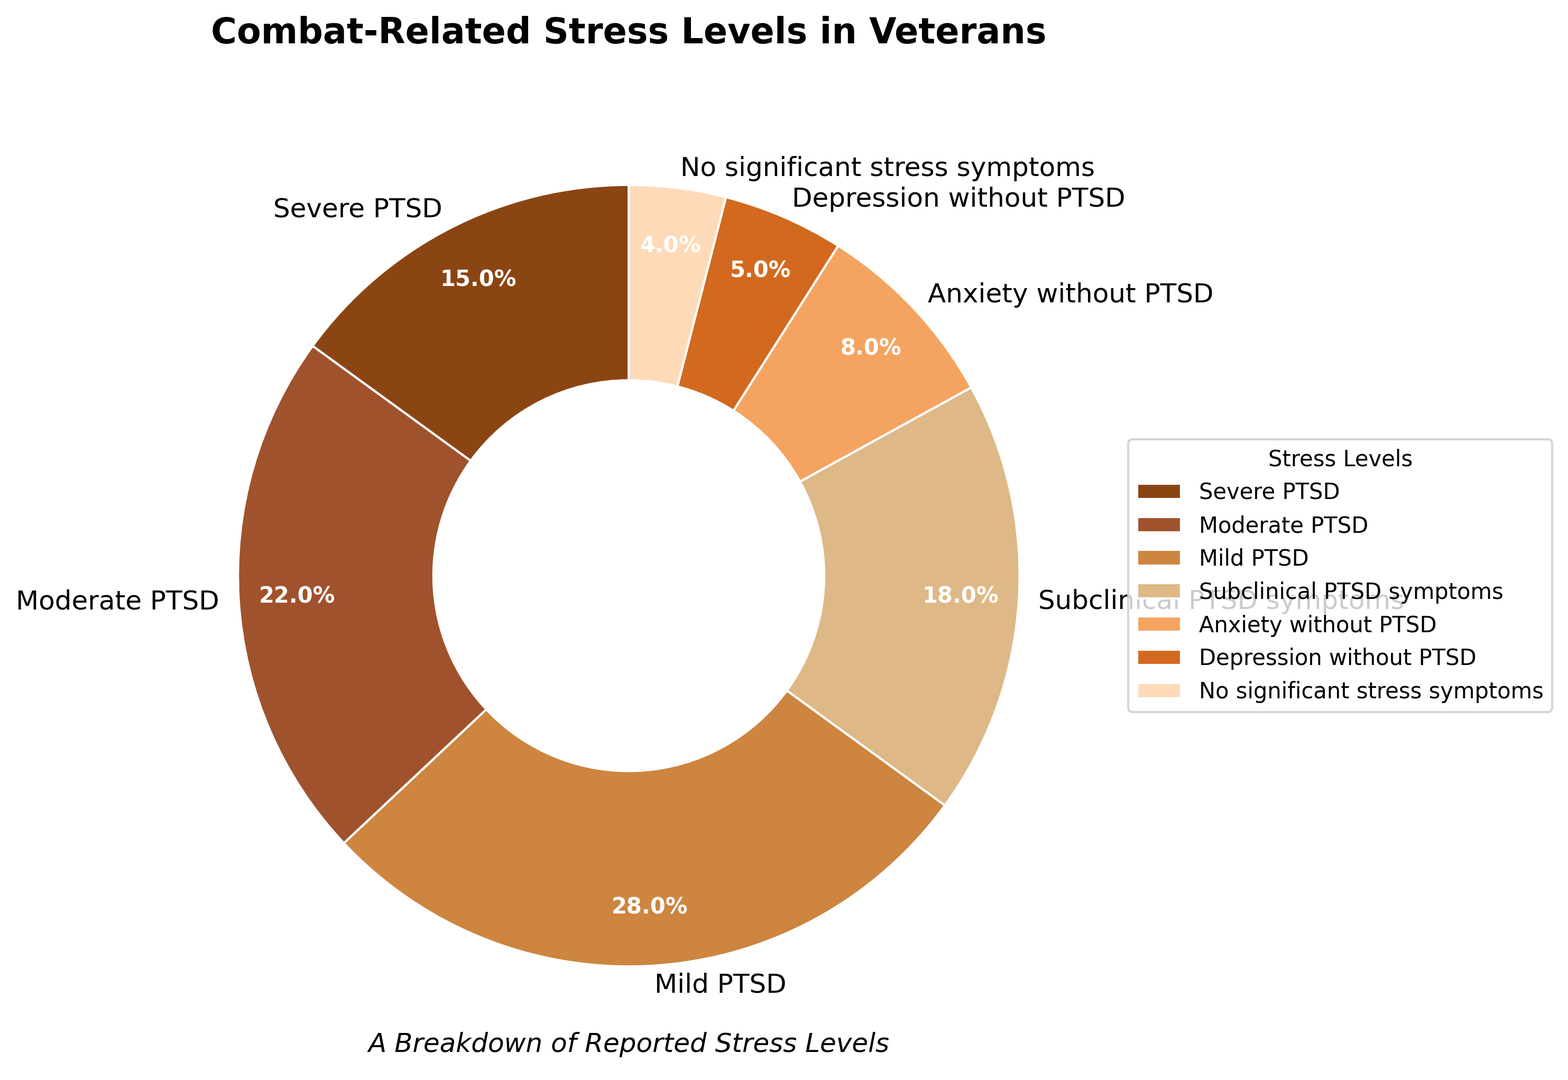Which stress level is reported by the highest percentage of veterans? By looking at the pie chart, the segment labeled "Mild PTSD" has the largest size. The percentage label confirms this as it shows 28%.
Answer: "Mild PTSD" What is the combined percentage of veterans reporting Severe and Moderate PTSD? The pie chart shows "Severe PTSD" at 15% and "Moderate PTSD" at 22%. Adding these together results in 15% + 22% = 37%.
Answer: 37% Which stress levels are reported by fewer than 10% of veterans? The segments labeled "Anxiety without PTSD" (8%), "Depression without PTSD" (5%), and "No significant stress symptoms" (4%) each show percentages under 10%.
Answer: "Anxiety without PTSD", "Depression without PTSD", "No significant stress symptoms" What percentage of veterans report any form of PTSD symptoms (including severe, moderate, mild, and subclinical)? The pie chart indicates the percentages for "Severe PTSD" (15%), "Moderate PTSD" (22%), "Mild PTSD" (28%), and "Subclinical PTSD symptoms" (18%). Adding these together gives 15% + 22% + 28% + 18% = 83%.
Answer: 83% Are there more veterans reporting anxiety without PTSD or depression without PTSD? By comparing the segments, the one labeled "Anxiety without PTSD" is larger and shows 8% compared to "Depression without PTSD," which is 5%.
Answer: "Anxiety without PTSD" Do more veterans report subclinical PTSD symptoms or moderate PTSD? By comparing the segments, "Moderate PTSD" (22%) is larger than "Subclinical PTSD symptoms" (18%).
Answer: "Moderate PTSD" Which stress level category makes up the smallest percentage of veterans? The segment labeled "No significant stress symptoms" is the smallest and shows 4%.
Answer: "No significant stress symptoms" How many veterans report moderate or severe PTSD combined, if the total number of surveyed veterans is 1000? The combined percentage for "Moderate PTSD" (22%) and "Severe PTSD" (15%) is 37%. To find the number, calculate 37% of 1000: 0.37 * 1000 = 370.
Answer: 370 What is the color associated with the segment for anxiety without PTSD? Observing the pie chart, the segment labeled "Anxiety without PTSD" is represented in a light orange color.
Answer: Light orange 